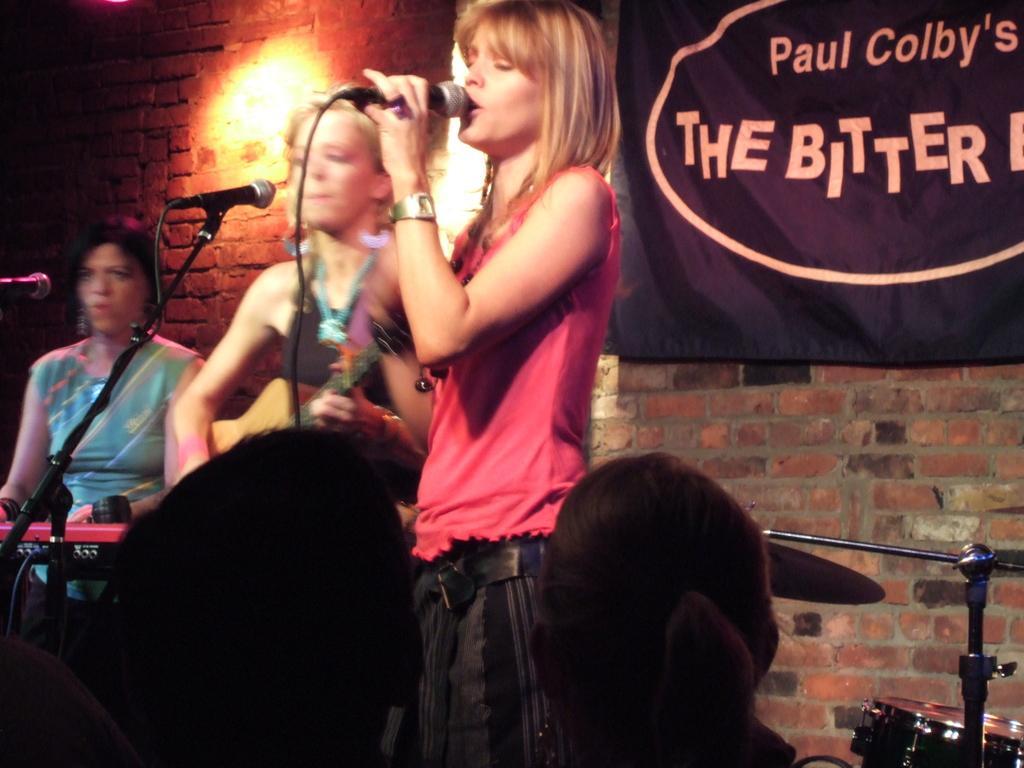Can you describe this image briefly? In this picture there is a woman standing and holding the microphone and she is singing. At the back there are two persons standing and playing musical instruments. On the right side of the image there is a banner on the wall and there is a text on the banner and there is a drum. At the back there is a light on the wall. 